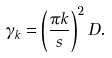<formula> <loc_0><loc_0><loc_500><loc_500>\gamma _ { k } = \left ( \frac { \pi k } { s } \right ) ^ { 2 } D .</formula> 